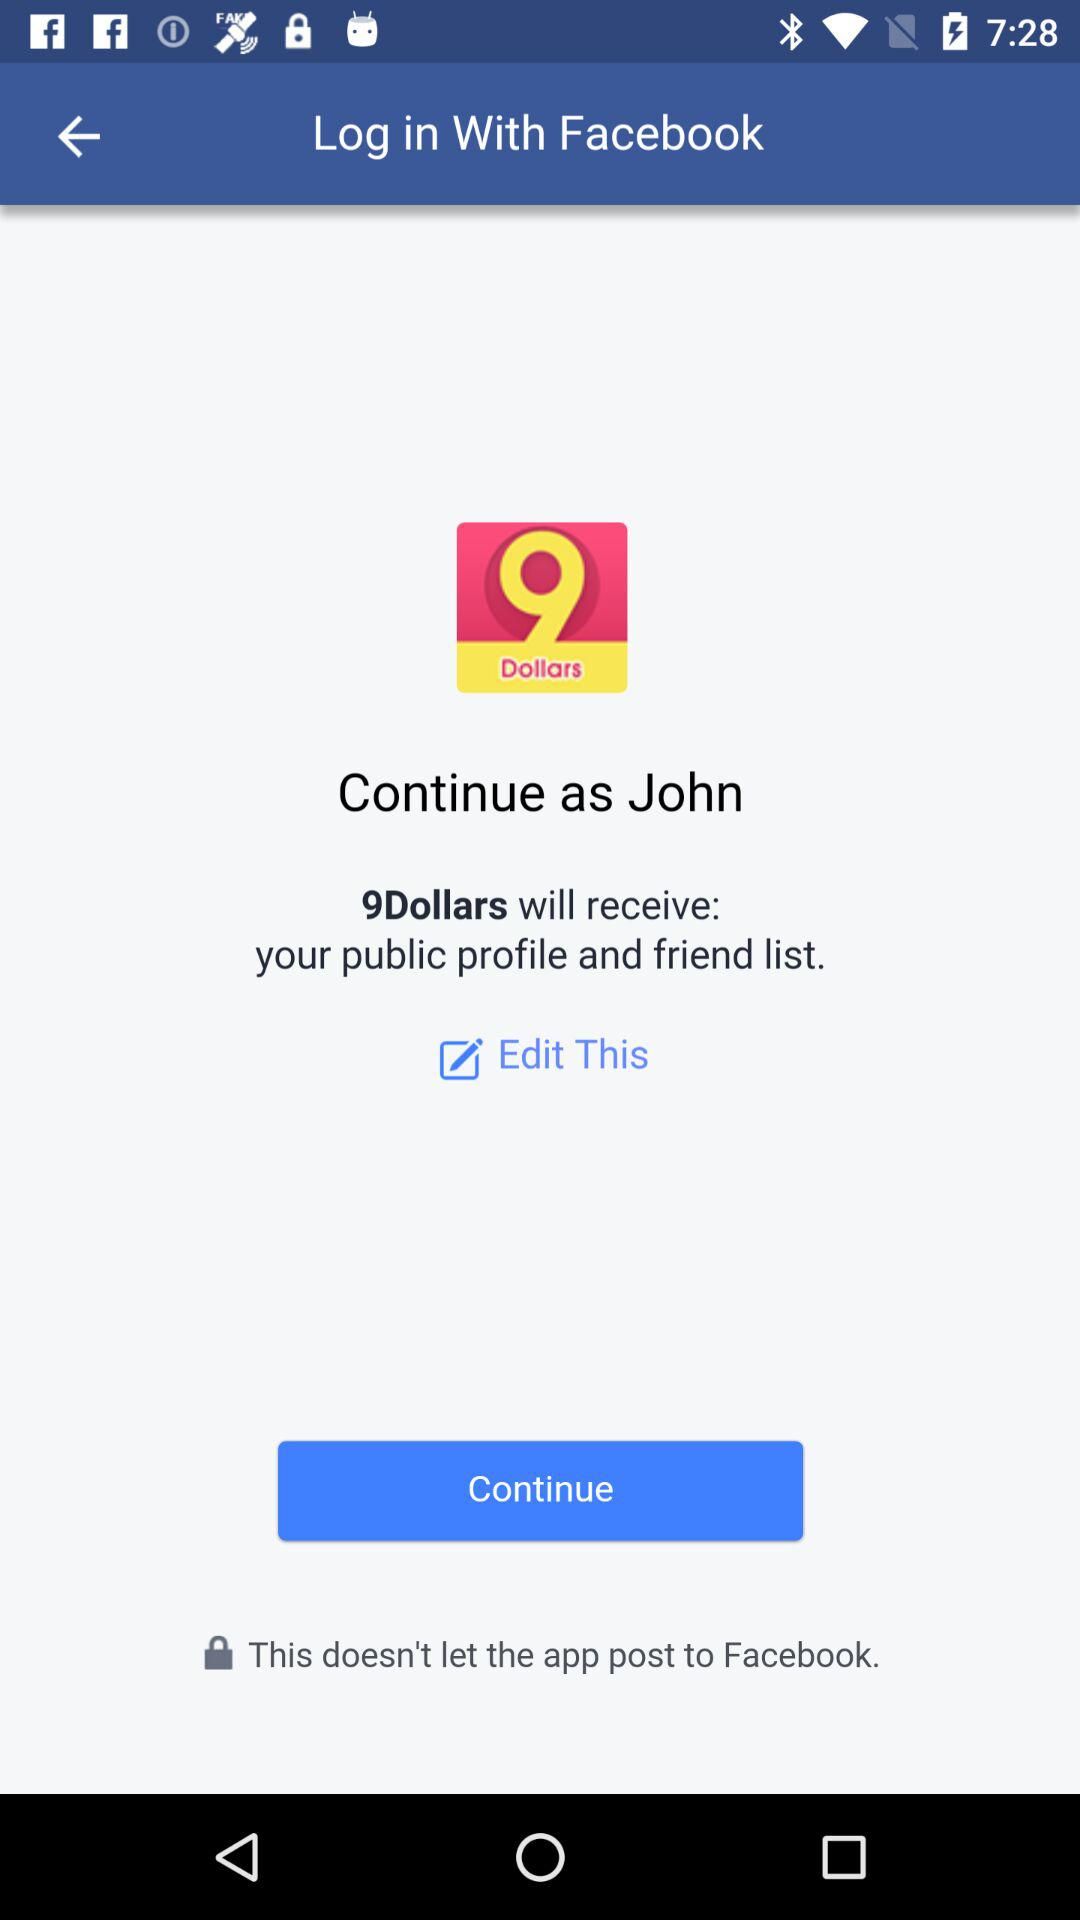Who will receive the public profile and friend list? The application "9Dollars" will receive the public profile and friend list. 